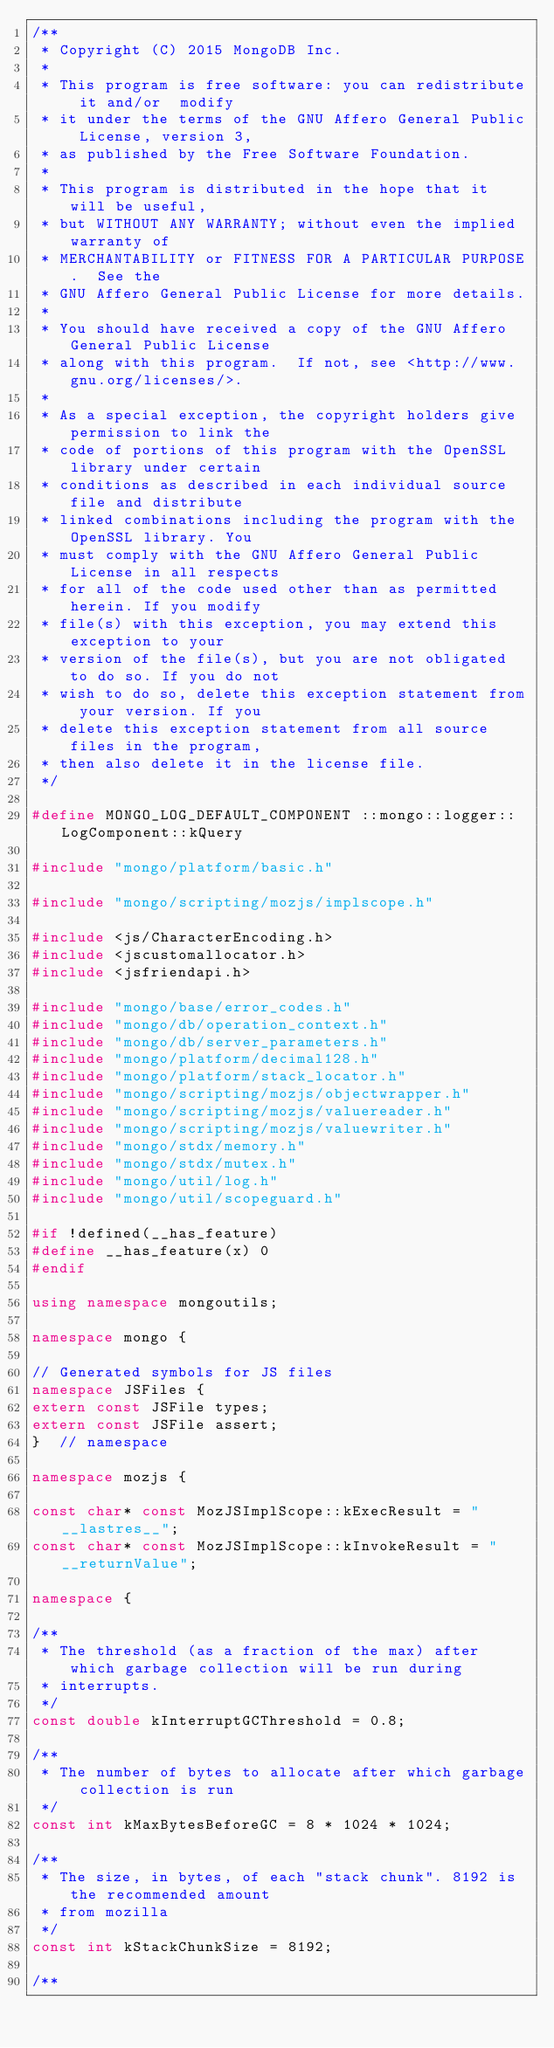Convert code to text. <code><loc_0><loc_0><loc_500><loc_500><_C++_>/**
 * Copyright (C) 2015 MongoDB Inc.
 *
 * This program is free software: you can redistribute it and/or  modify
 * it under the terms of the GNU Affero General Public License, version 3,
 * as published by the Free Software Foundation.
 *
 * This program is distributed in the hope that it will be useful,
 * but WITHOUT ANY WARRANTY; without even the implied warranty of
 * MERCHANTABILITY or FITNESS FOR A PARTICULAR PURPOSE.  See the
 * GNU Affero General Public License for more details.
 *
 * You should have received a copy of the GNU Affero General Public License
 * along with this program.  If not, see <http://www.gnu.org/licenses/>.
 *
 * As a special exception, the copyright holders give permission to link the
 * code of portions of this program with the OpenSSL library under certain
 * conditions as described in each individual source file and distribute
 * linked combinations including the program with the OpenSSL library. You
 * must comply with the GNU Affero General Public License in all respects
 * for all of the code used other than as permitted herein. If you modify
 * file(s) with this exception, you may extend this exception to your
 * version of the file(s), but you are not obligated to do so. If you do not
 * wish to do so, delete this exception statement from your version. If you
 * delete this exception statement from all source files in the program,
 * then also delete it in the license file.
 */

#define MONGO_LOG_DEFAULT_COMPONENT ::mongo::logger::LogComponent::kQuery

#include "mongo/platform/basic.h"

#include "mongo/scripting/mozjs/implscope.h"

#include <js/CharacterEncoding.h>
#include <jscustomallocator.h>
#include <jsfriendapi.h>

#include "mongo/base/error_codes.h"
#include "mongo/db/operation_context.h"
#include "mongo/db/server_parameters.h"
#include "mongo/platform/decimal128.h"
#include "mongo/platform/stack_locator.h"
#include "mongo/scripting/mozjs/objectwrapper.h"
#include "mongo/scripting/mozjs/valuereader.h"
#include "mongo/scripting/mozjs/valuewriter.h"
#include "mongo/stdx/memory.h"
#include "mongo/stdx/mutex.h"
#include "mongo/util/log.h"
#include "mongo/util/scopeguard.h"

#if !defined(__has_feature)
#define __has_feature(x) 0
#endif

using namespace mongoutils;

namespace mongo {

// Generated symbols for JS files
namespace JSFiles {
extern const JSFile types;
extern const JSFile assert;
}  // namespace

namespace mozjs {

const char* const MozJSImplScope::kExecResult = "__lastres__";
const char* const MozJSImplScope::kInvokeResult = "__returnValue";

namespace {

/**
 * The threshold (as a fraction of the max) after which garbage collection will be run during
 * interrupts.
 */
const double kInterruptGCThreshold = 0.8;

/**
 * The number of bytes to allocate after which garbage collection is run
 */
const int kMaxBytesBeforeGC = 8 * 1024 * 1024;

/**
 * The size, in bytes, of each "stack chunk". 8192 is the recommended amount
 * from mozilla
 */
const int kStackChunkSize = 8192;

/**</code> 